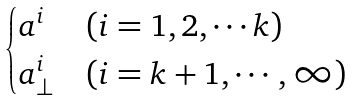Convert formula to latex. <formula><loc_0><loc_0><loc_500><loc_500>\begin{cases} a ^ { i } & ( i = 1 , 2 , \cdots k ) \\ a ^ { i } _ { \bot } & ( i = k + 1 , \cdots , \infty ) \\ \end{cases}</formula> 